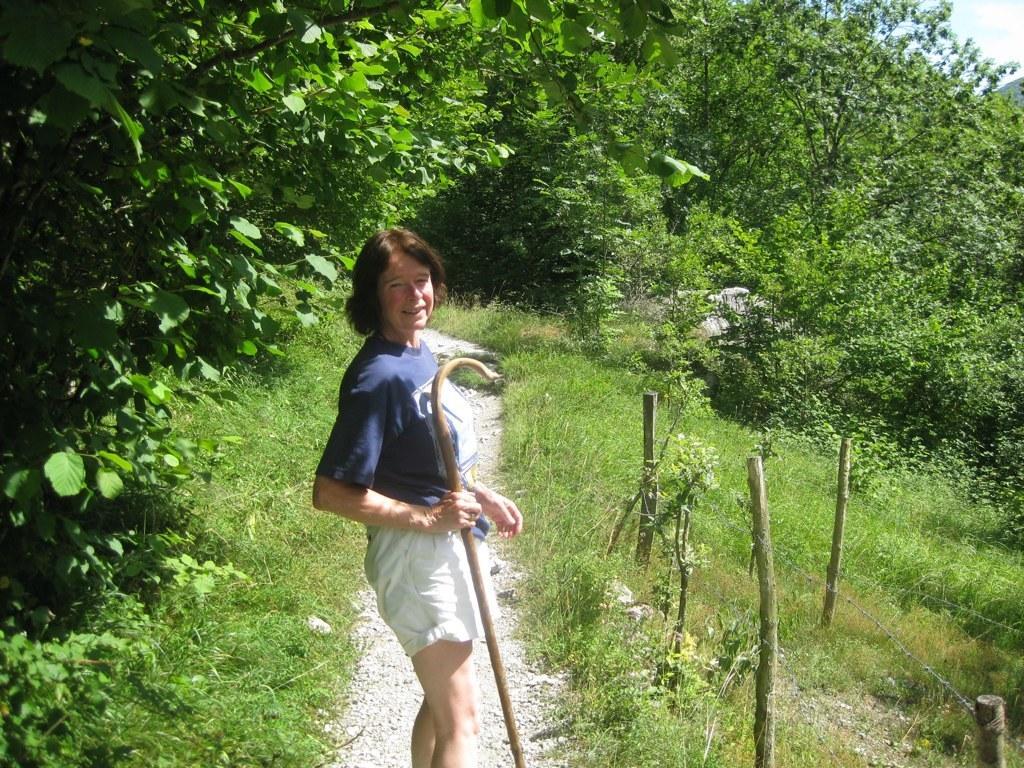Describe this image in one or two sentences. In the picture there is a woman standing in between the grass and around her there are many trees, she is holding a wooden stick in her hand. 